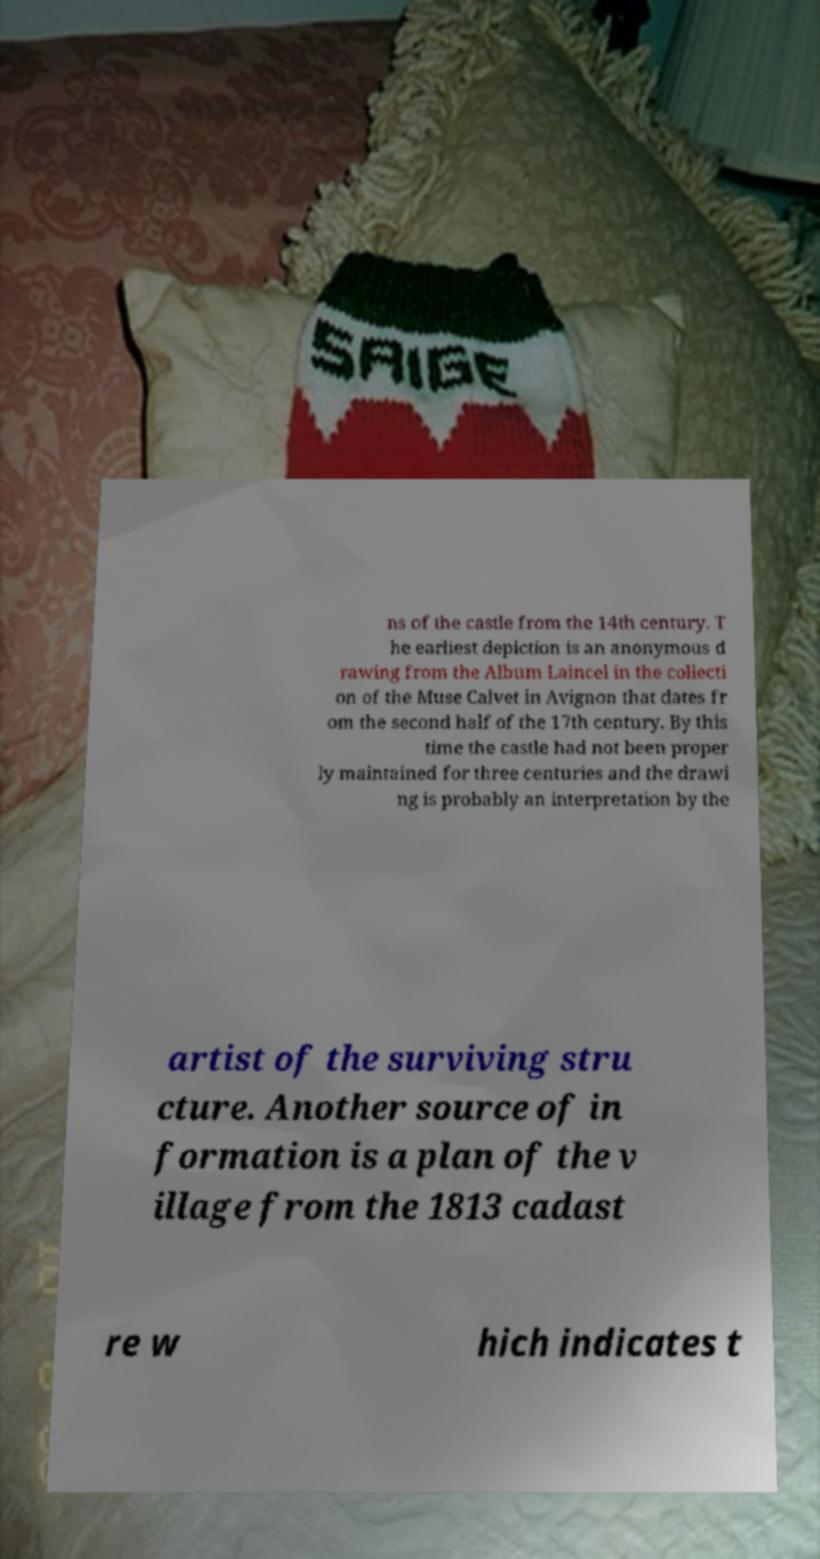I need the written content from this picture converted into text. Can you do that? ns of the castle from the 14th century. T he earliest depiction is an anonymous d rawing from the Album Laincel in the collecti on of the Muse Calvet in Avignon that dates fr om the second half of the 17th century. By this time the castle had not been proper ly maintained for three centuries and the drawi ng is probably an interpretation by the artist of the surviving stru cture. Another source of in formation is a plan of the v illage from the 1813 cadast re w hich indicates t 